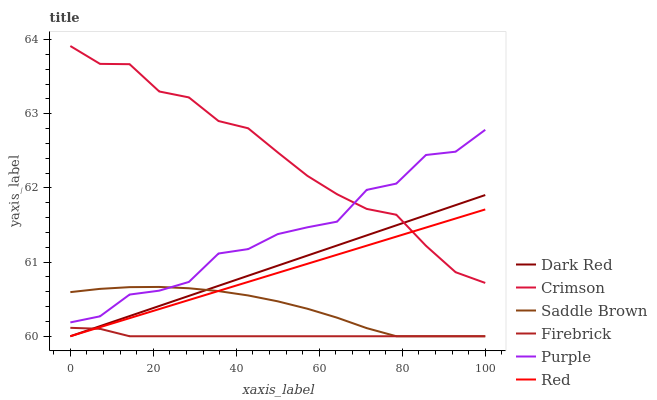Does Dark Red have the minimum area under the curve?
Answer yes or no. No. Does Dark Red have the maximum area under the curve?
Answer yes or no. No. Is Dark Red the smoothest?
Answer yes or no. No. Is Dark Red the roughest?
Answer yes or no. No. Does Crimson have the lowest value?
Answer yes or no. No. Does Dark Red have the highest value?
Answer yes or no. No. Is Saddle Brown less than Crimson?
Answer yes or no. Yes. Is Purple greater than Dark Red?
Answer yes or no. Yes. Does Saddle Brown intersect Crimson?
Answer yes or no. No. 